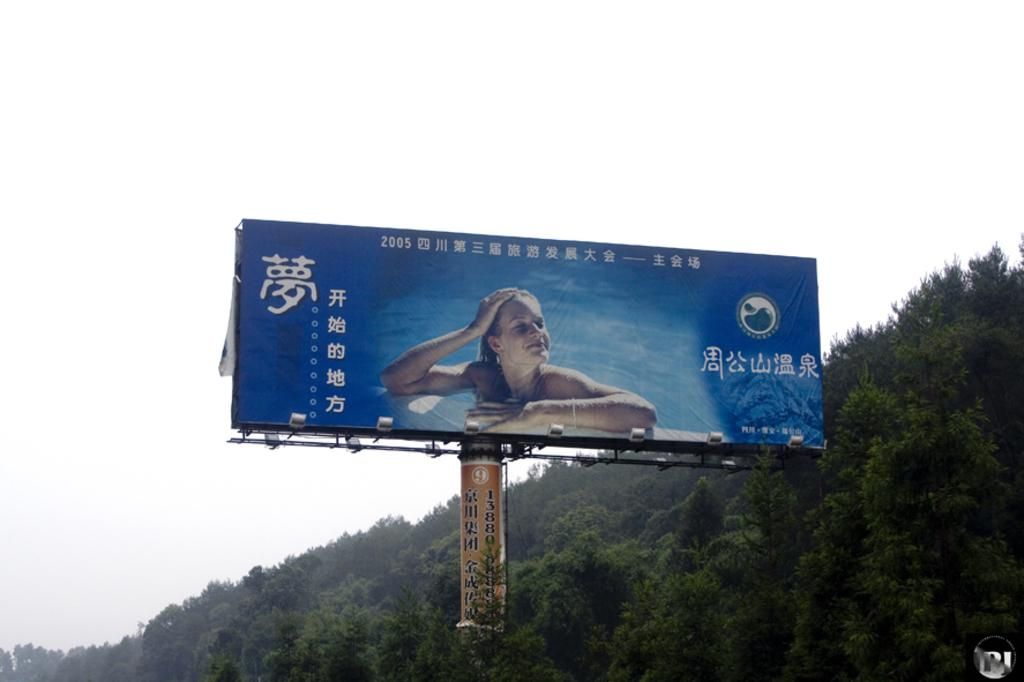What is the main subject in the image? There is a hoarding in the image. Can you describe the background of the image? There are trees in the background of the image. What type of eggnog can be seen on the hoarding in the image? There is no eggnog present on the hoarding in the image. Is there a fight happening in the image? There is no indication of a fight in the image; it only features a hoarding and trees in the background. 